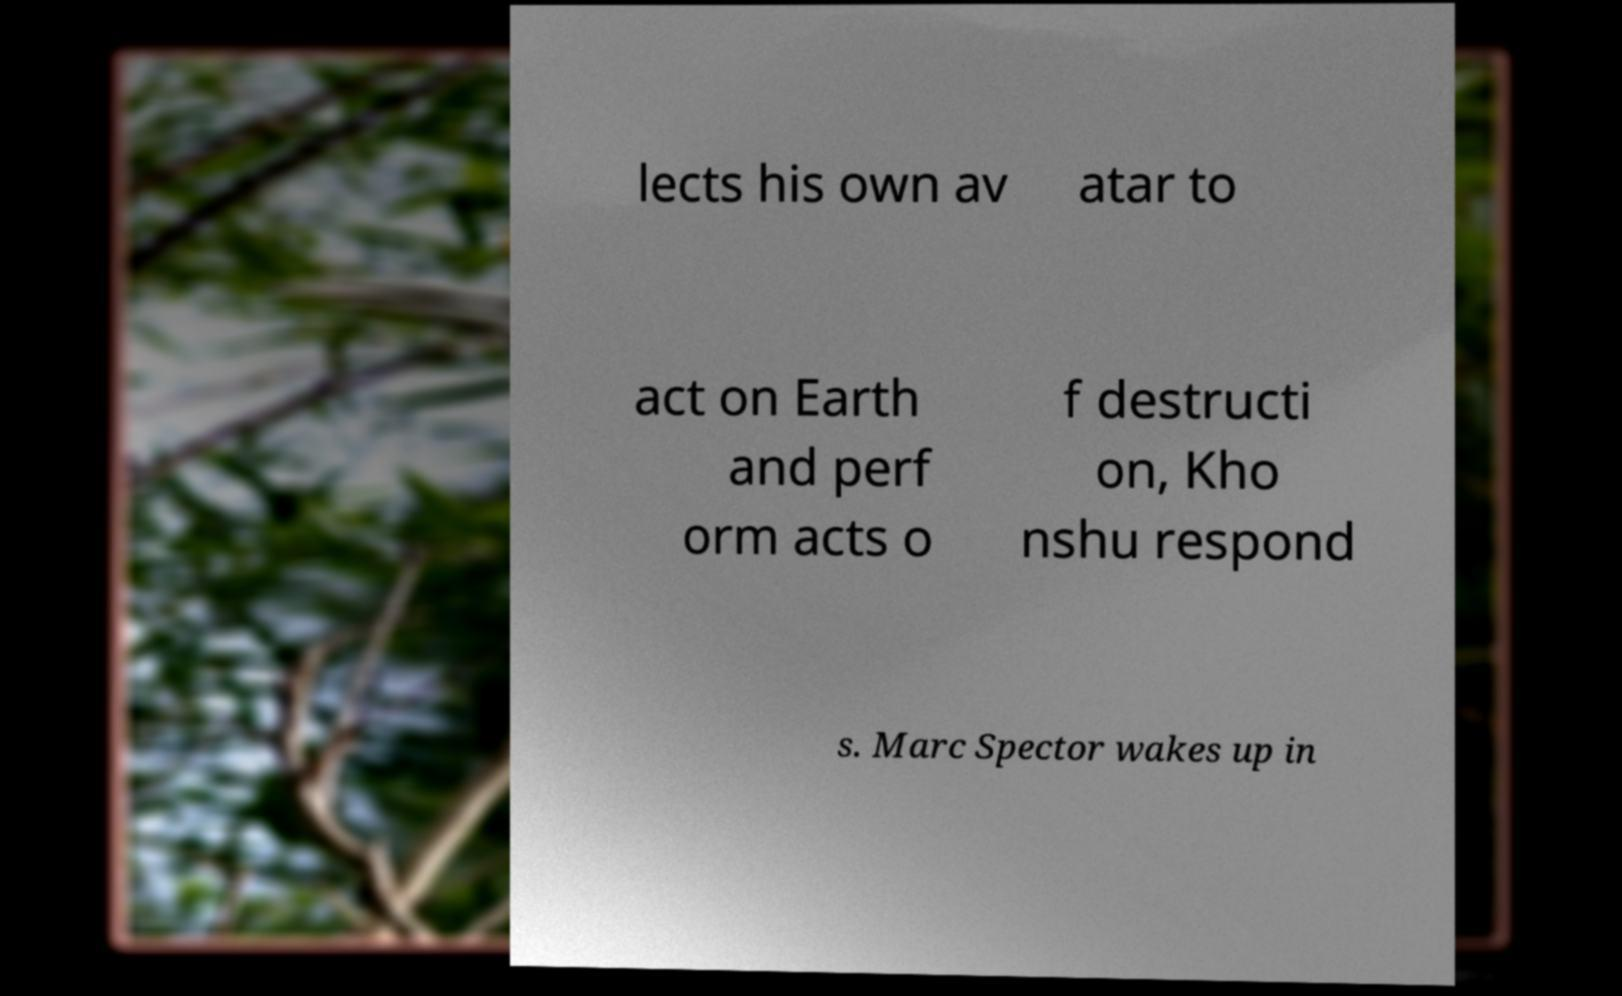Could you extract and type out the text from this image? lects his own av atar to act on Earth and perf orm acts o f destructi on, Kho nshu respond s. Marc Spector wakes up in 